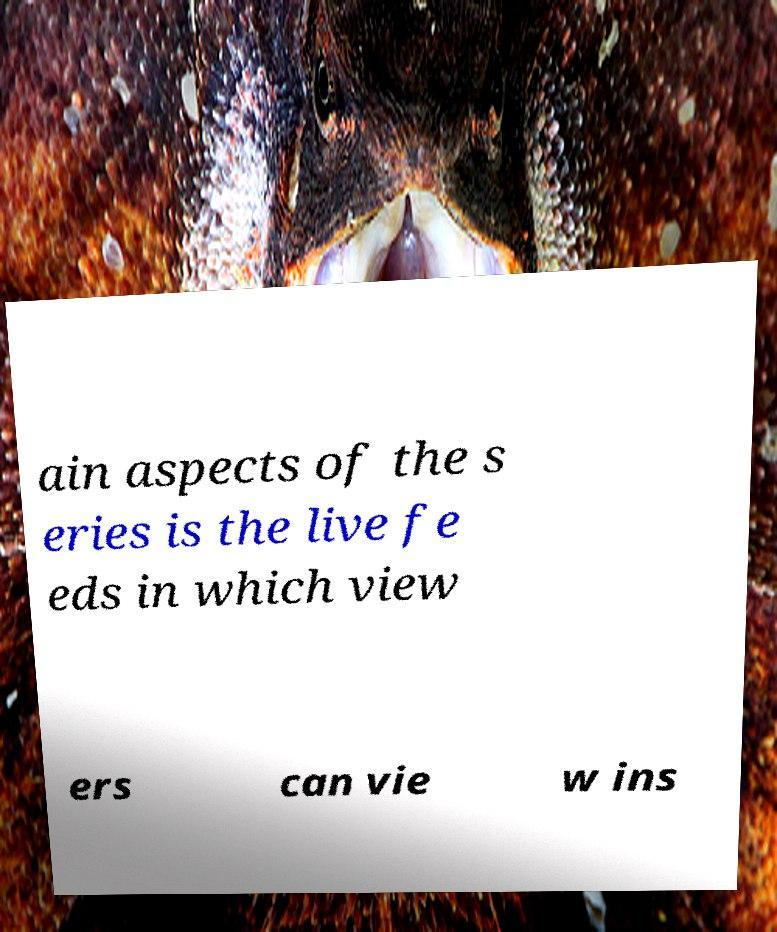Could you extract and type out the text from this image? ain aspects of the s eries is the live fe eds in which view ers can vie w ins 